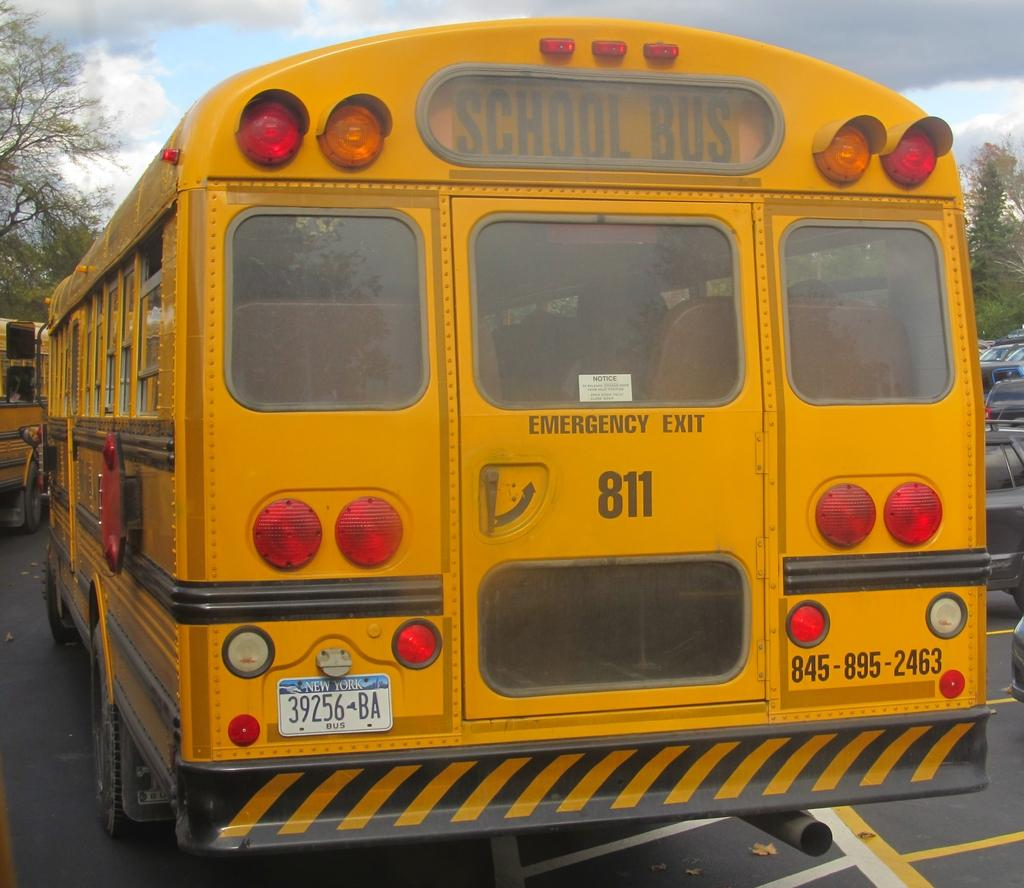What type of vehicle is on the road in the image? There is a bus on the road in the image. Can you describe the traffic situation in the image? There are vehicles in the background on the road in the image. What can be seen in the background besides the vehicles? There are trees in the background of the image. What is visible in the sky in the image? There are clouds in the sky in the image. What type of sugar is being sold at the harbor in the image? There is no harbor or sugar present in the image; it features a bus on the road with vehicles in the background, trees, and clouds in the sky. 